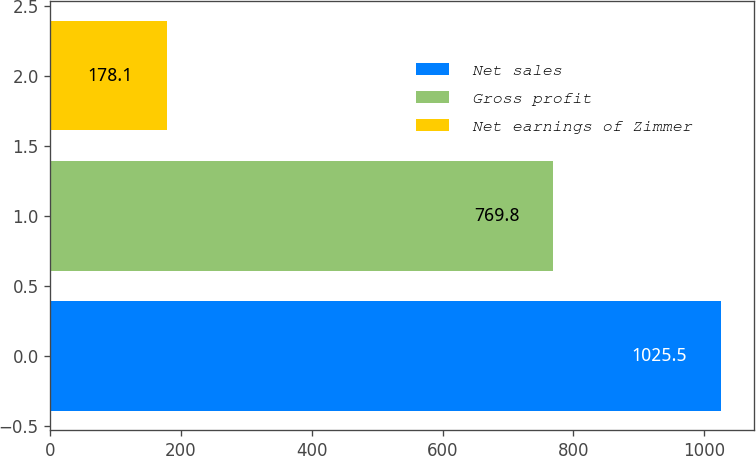<chart> <loc_0><loc_0><loc_500><loc_500><bar_chart><fcel>Net sales<fcel>Gross profit<fcel>Net earnings of Zimmer<nl><fcel>1025.5<fcel>769.8<fcel>178.1<nl></chart> 